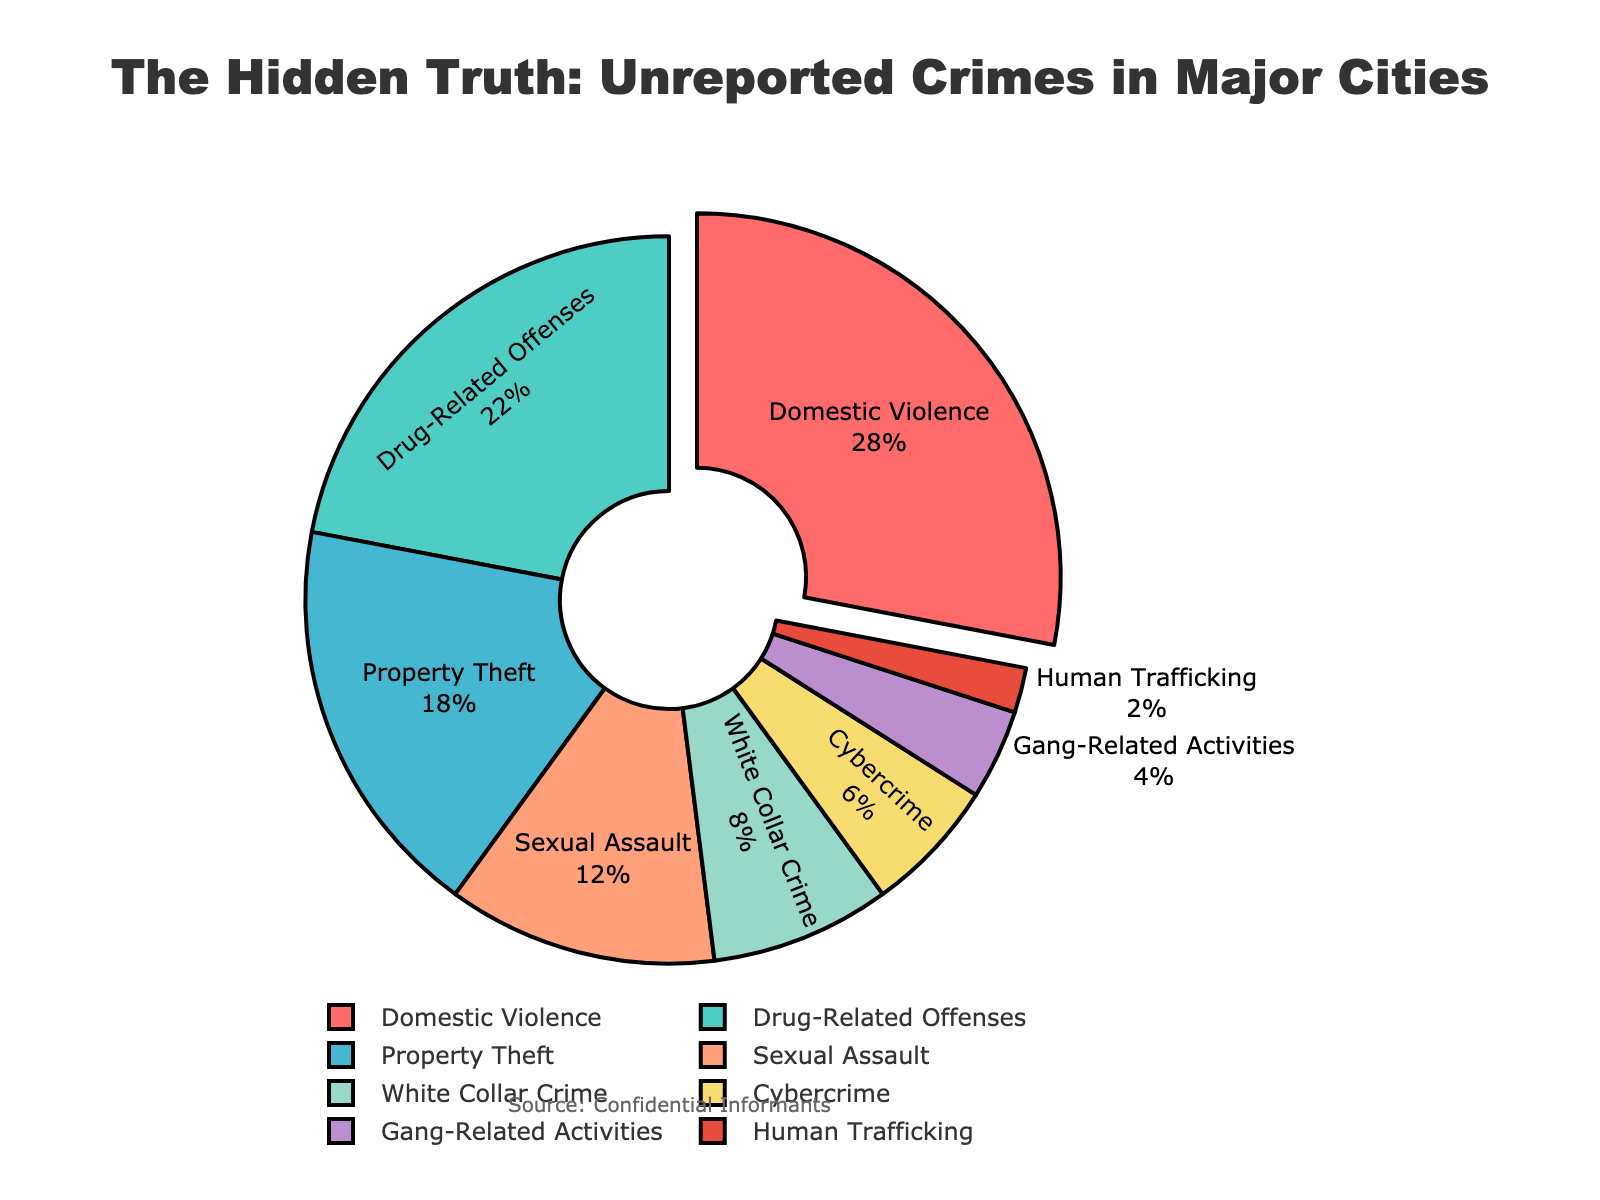Which type of unreported crime has the highest percentage? The slice with the largest 'pull' and size represents the type with the highest percentage, which is Domestic Violence at 28%.
Answer: Domestic Violence Which type of unreported crime has the lowest percentage? Look for the smallest segment in the pie chart. The smallest segment represents Human Trafficking at 2%.
Answer: Human Trafficking Are Drug-Related Offenses more frequent than Sexual Assault and Cybercrime combined? The percentage for Drug-Related Offenses is 22%. Adding the percentages for Sexual Assault and Cybercrime gives 12% + 6% = 18%. Since 22% is greater than 18%, Drug-Related Offenses are more frequent.
Answer: Yes Which types of unreported crimes sum up to more than 50% of the pie chart? Summing the percentages starting from the highest and proceeding downwards: Domestic Violence (28%) + Drug-Related Offenses (22%) = 50%. Since we reached exactly 50% at this point, we look at the next type: Property Theft. Adding 18% surpasses 50%. So, Domestic Violence and Drug-Related Offenses together sum up to exactly 50%. If we are looking for types summing to 'more' than 50%, we would include the next grouping, which would be 51%, Domestic Violence (28%), Drug-Related Offenses (22%), and Property Theft (18%).
Answer: Domestic Violence, Drug-Related Offenses, Property Theft Is Property Theft more frequent than White Collar Crime and Gang-Related Activities combined? The percentage for Property Theft is 18%. Adding the percentages for White Collar Crime and Gang-Related Activities gives 8% + 4% = 12%. Since 18% is greater than 12%, Property Theft is more frequent.
Answer: Yes How many types of crimes have a percentage less than 10%? Identify the segments with percentages less than 10%. These are White Collar Crime (8%), Cybercrime (6%), Gang-Related Activities (4%), and Human Trafficking (2%). There are 4 such types.
Answer: 4 Which color represents the type of crime with the second-highest unreported percentage? The second-highest unreported percentage is Drug-Related Offenses at 22%. Referring to the color legend, Drug-Related Offenses are represented by the color green.
Answer: Green What's the combined percentage of Cybercrime, Gang-Related Activities, and Human Trafficking? Adding the percentages for Cybercrime (6%), Gang-Related Activities (4%), and Human Trafficking (2%) gives 6% + 4% + 2% = 12%.
Answer: 12% If we consider crimes with percentages above 20% as 'high frequency', which types fall into this category? The types with percentages above 20% are Domestic Violence (28%) and Drug-Related Offenses (22%).
Answer: Domestic Violence, Drug-Related Offenses 